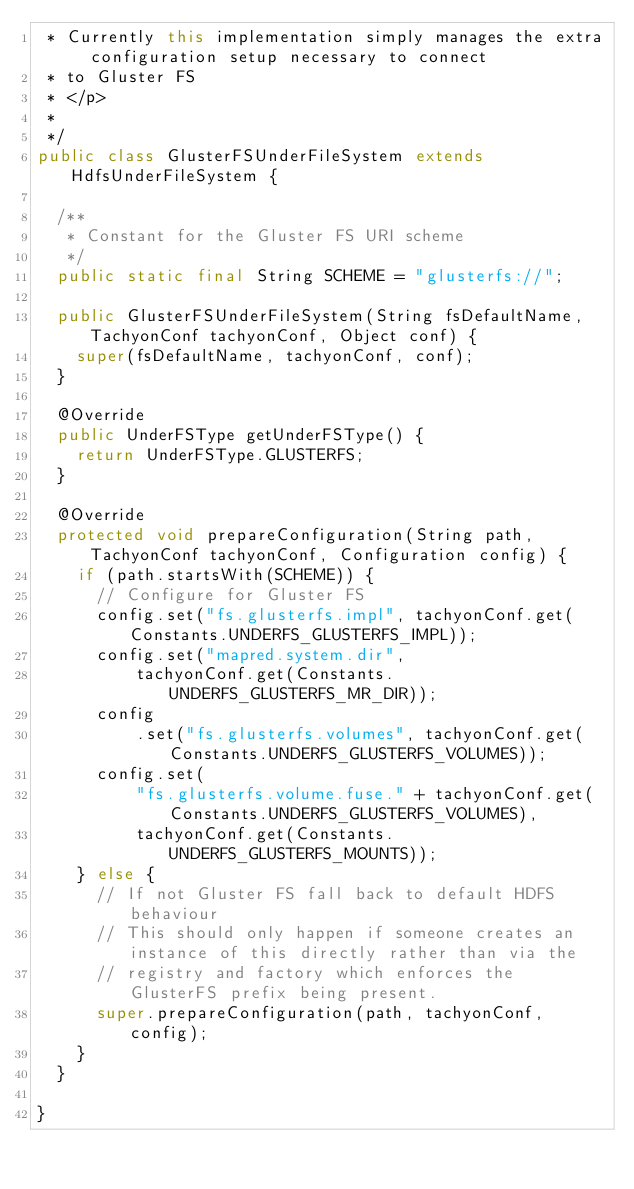<code> <loc_0><loc_0><loc_500><loc_500><_Java_> * Currently this implementation simply manages the extra configuration setup necessary to connect
 * to Gluster FS
 * </p>
 *
 */
public class GlusterFSUnderFileSystem extends HdfsUnderFileSystem {

  /**
   * Constant for the Gluster FS URI scheme
   */
  public static final String SCHEME = "glusterfs://";

  public GlusterFSUnderFileSystem(String fsDefaultName, TachyonConf tachyonConf, Object conf) {
    super(fsDefaultName, tachyonConf, conf);
  }

  @Override
  public UnderFSType getUnderFSType() {
    return UnderFSType.GLUSTERFS;
  }

  @Override
  protected void prepareConfiguration(String path, TachyonConf tachyonConf, Configuration config) {
    if (path.startsWith(SCHEME)) {
      // Configure for Gluster FS
      config.set("fs.glusterfs.impl", tachyonConf.get(Constants.UNDERFS_GLUSTERFS_IMPL));
      config.set("mapred.system.dir",
          tachyonConf.get(Constants.UNDERFS_GLUSTERFS_MR_DIR));
      config
          .set("fs.glusterfs.volumes", tachyonConf.get(Constants.UNDERFS_GLUSTERFS_VOLUMES));
      config.set(
          "fs.glusterfs.volume.fuse." + tachyonConf.get(Constants.UNDERFS_GLUSTERFS_VOLUMES),
          tachyonConf.get(Constants.UNDERFS_GLUSTERFS_MOUNTS));
    } else {
      // If not Gluster FS fall back to default HDFS behaviour
      // This should only happen if someone creates an instance of this directly rather than via the
      // registry and factory which enforces the GlusterFS prefix being present.
      super.prepareConfiguration(path, tachyonConf, config);
    }
  }

}
</code> 